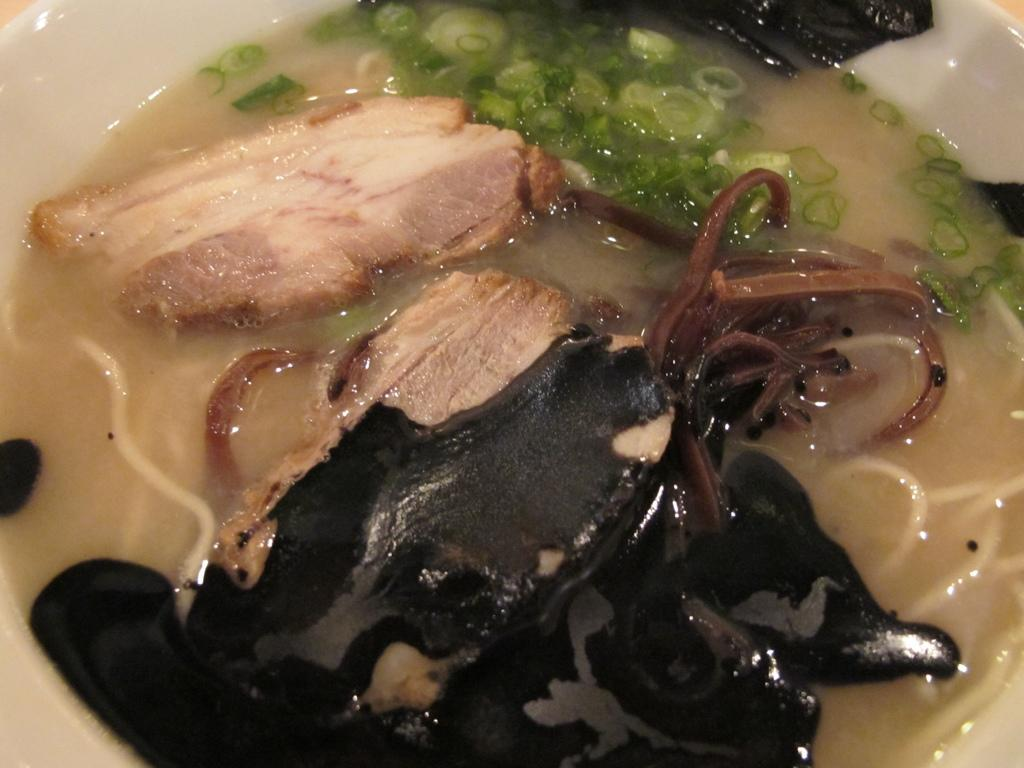What is the main subject in the image? There is a food item in a bowl in the image. What type of harmony can be heard in the background of the image? There is no background music or sound present in the image, so it is not possible to determine what type of harmony might be heard. 